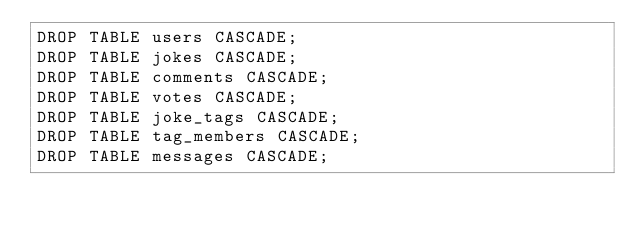Convert code to text. <code><loc_0><loc_0><loc_500><loc_500><_SQL_>DROP TABLE users CASCADE;
DROP TABLE jokes CASCADE;
DROP TABLE comments CASCADE;
DROP TABLE votes CASCADE;
DROP TABLE joke_tags CASCADE;
DROP TABLE tag_members CASCADE;
DROP TABLE messages CASCADE;
</code> 